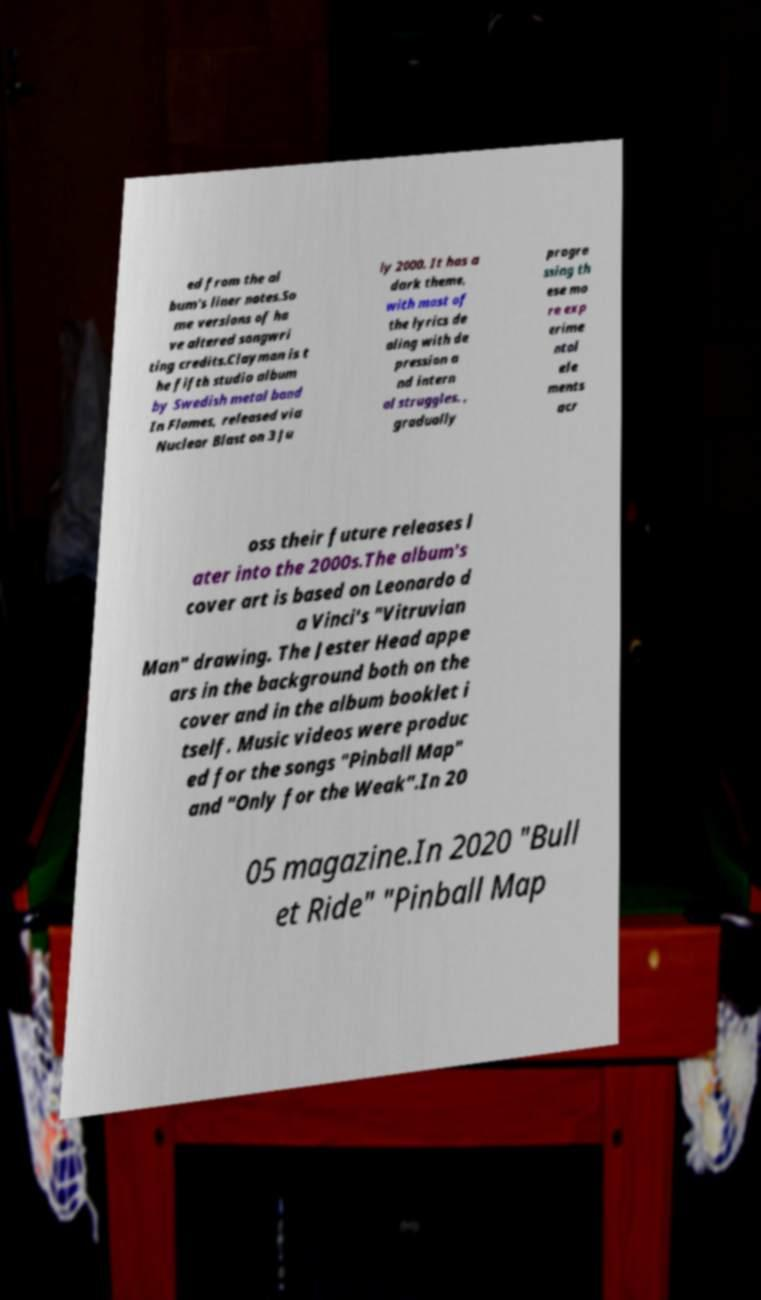For documentation purposes, I need the text within this image transcribed. Could you provide that? ed from the al bum's liner notes.So me versions of ha ve altered songwri ting credits.Clayman is t he fifth studio album by Swedish metal band In Flames, released via Nuclear Blast on 3 Ju ly 2000. It has a dark theme, with most of the lyrics de aling with de pression a nd intern al struggles. , gradually progre ssing th ese mo re exp erime ntal ele ments acr oss their future releases l ater into the 2000s.The album's cover art is based on Leonardo d a Vinci's "Vitruvian Man" drawing. The Jester Head appe ars in the background both on the cover and in the album booklet i tself. Music videos were produc ed for the songs "Pinball Map" and "Only for the Weak".In 20 05 magazine.In 2020 "Bull et Ride" "Pinball Map 